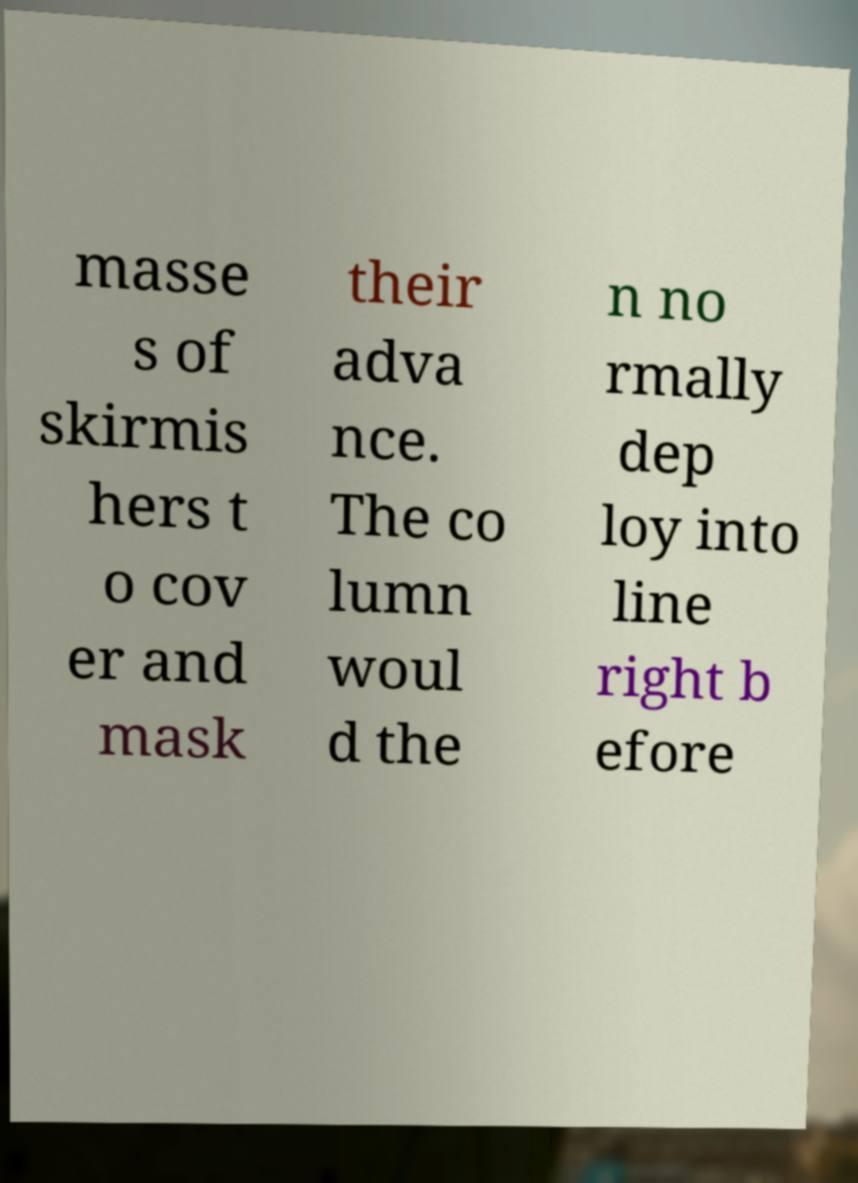For documentation purposes, I need the text within this image transcribed. Could you provide that? masse s of skirmis hers t o cov er and mask their adva nce. The co lumn woul d the n no rmally dep loy into line right b efore 